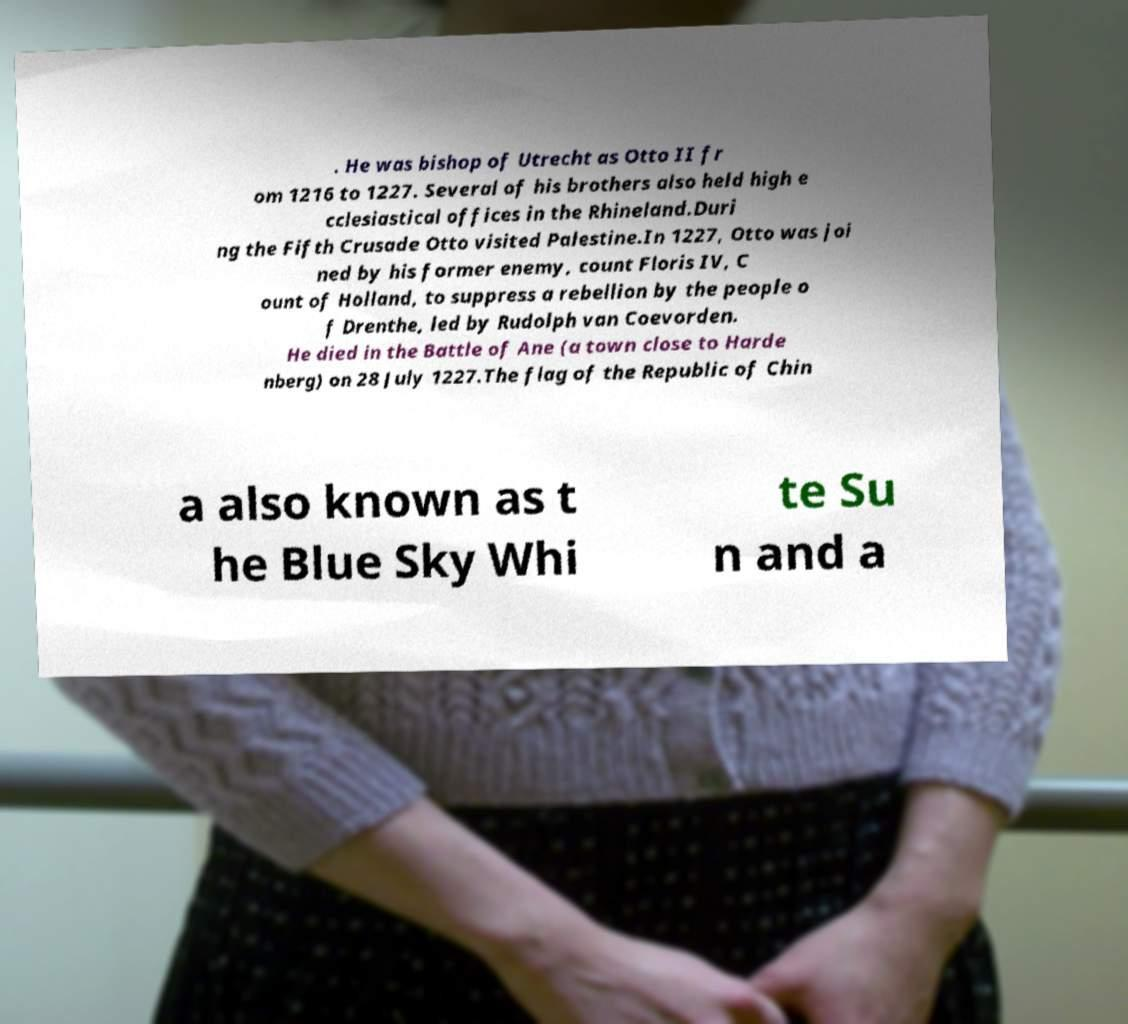Could you extract and type out the text from this image? . He was bishop of Utrecht as Otto II fr om 1216 to 1227. Several of his brothers also held high e cclesiastical offices in the Rhineland.Duri ng the Fifth Crusade Otto visited Palestine.In 1227, Otto was joi ned by his former enemy, count Floris IV, C ount of Holland, to suppress a rebellion by the people o f Drenthe, led by Rudolph van Coevorden. He died in the Battle of Ane (a town close to Harde nberg) on 28 July 1227.The flag of the Republic of Chin a also known as t he Blue Sky Whi te Su n and a 